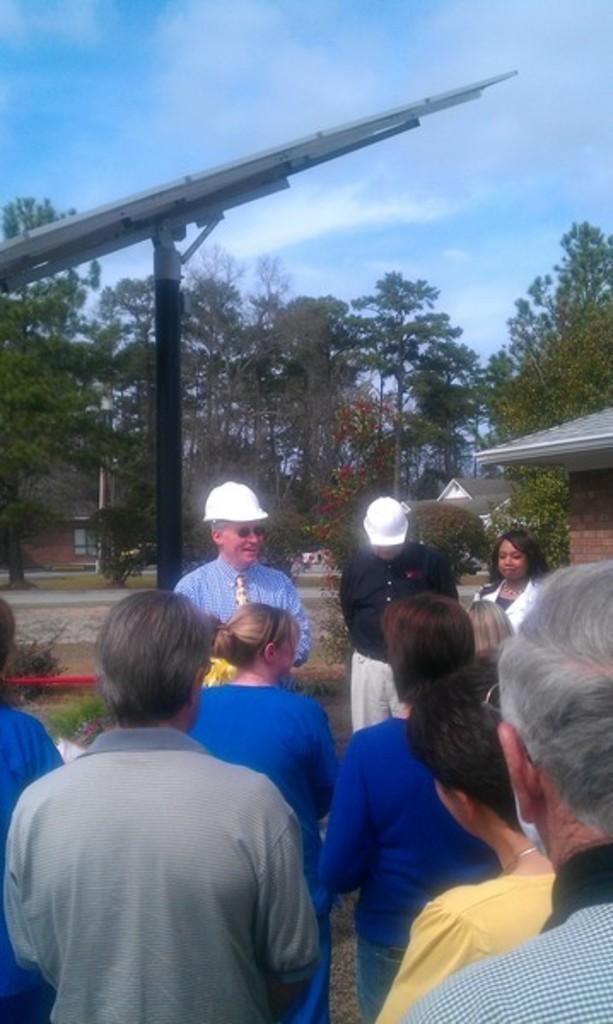How many people are in the image? There are people standing in the image, but the exact number is not specified. What are two of the people wearing? Two of the people are wearing white helmets. What can be seen in the background of the image? Trees, clouds, the sky, and grass are visible in the background of the image. What type of neck is visible on the trees in the image? There are no necks present on the trees in the image, as trees do not have necks. What is being served for dinner in the image? There is no dinner being served in the image; it only features people standing and the background. 